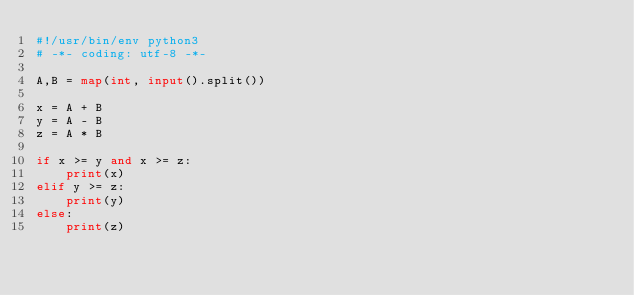<code> <loc_0><loc_0><loc_500><loc_500><_Python_>#!/usr/bin/env python3
# -*- coding: utf-8 -*-

A,B = map(int, input().split())

x = A + B
y = A - B
z = A * B

if x >= y and x >= z:
    print(x)
elif y >= z:
    print(y)
else:
    print(z)</code> 